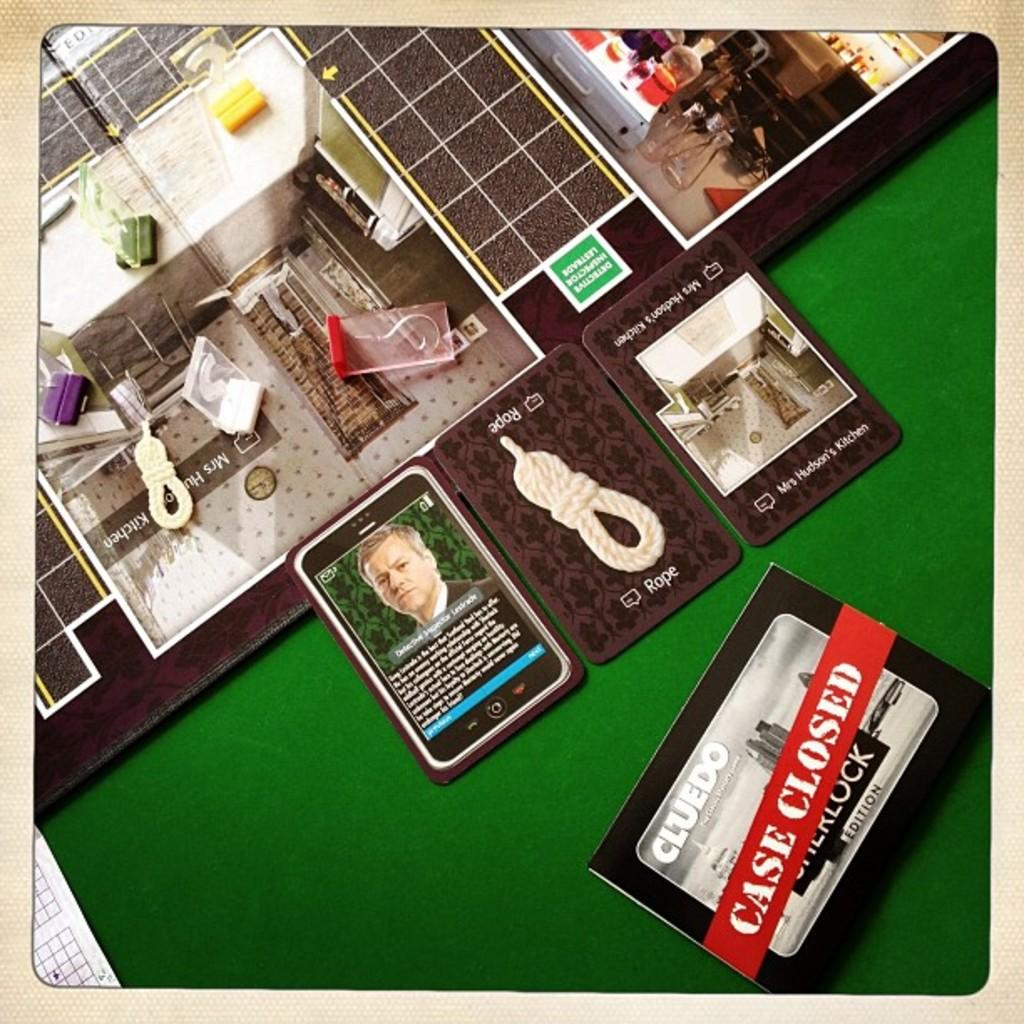<image>
Provide a brief description of the given image. Game cards from the game Clue are laid next to each other. 